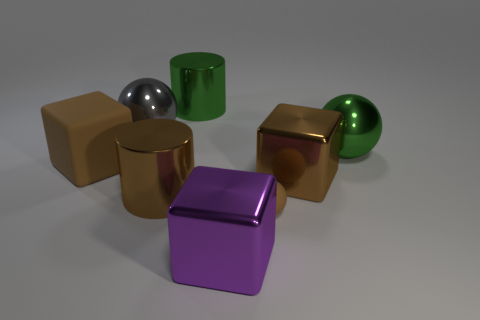What number of other objects are the same shape as the big purple metallic object?
Give a very brief answer. 2. Is the number of small balls behind the big gray sphere the same as the number of big green objects that are in front of the big green metal ball?
Your response must be concise. Yes. Is there another purple matte thing of the same size as the purple object?
Make the answer very short. No. What is the size of the gray shiny sphere?
Provide a succinct answer. Large. Are there an equal number of purple metal cubes that are to the right of the big green metal sphere and large green matte balls?
Give a very brief answer. Yes. What number of other things are the same color as the big matte block?
Keep it short and to the point. 3. The large block that is both behind the brown rubber sphere and on the left side of the brown ball is what color?
Keep it short and to the point. Brown. There is a ball in front of the big metallic cylinder that is to the left of the shiny cylinder behind the green ball; how big is it?
Offer a terse response. Small. What number of things are shiny cylinders that are behind the large brown shiny cylinder or shiny cylinders that are behind the large gray metallic thing?
Your response must be concise. 1. What is the shape of the large gray thing?
Your answer should be compact. Sphere. 